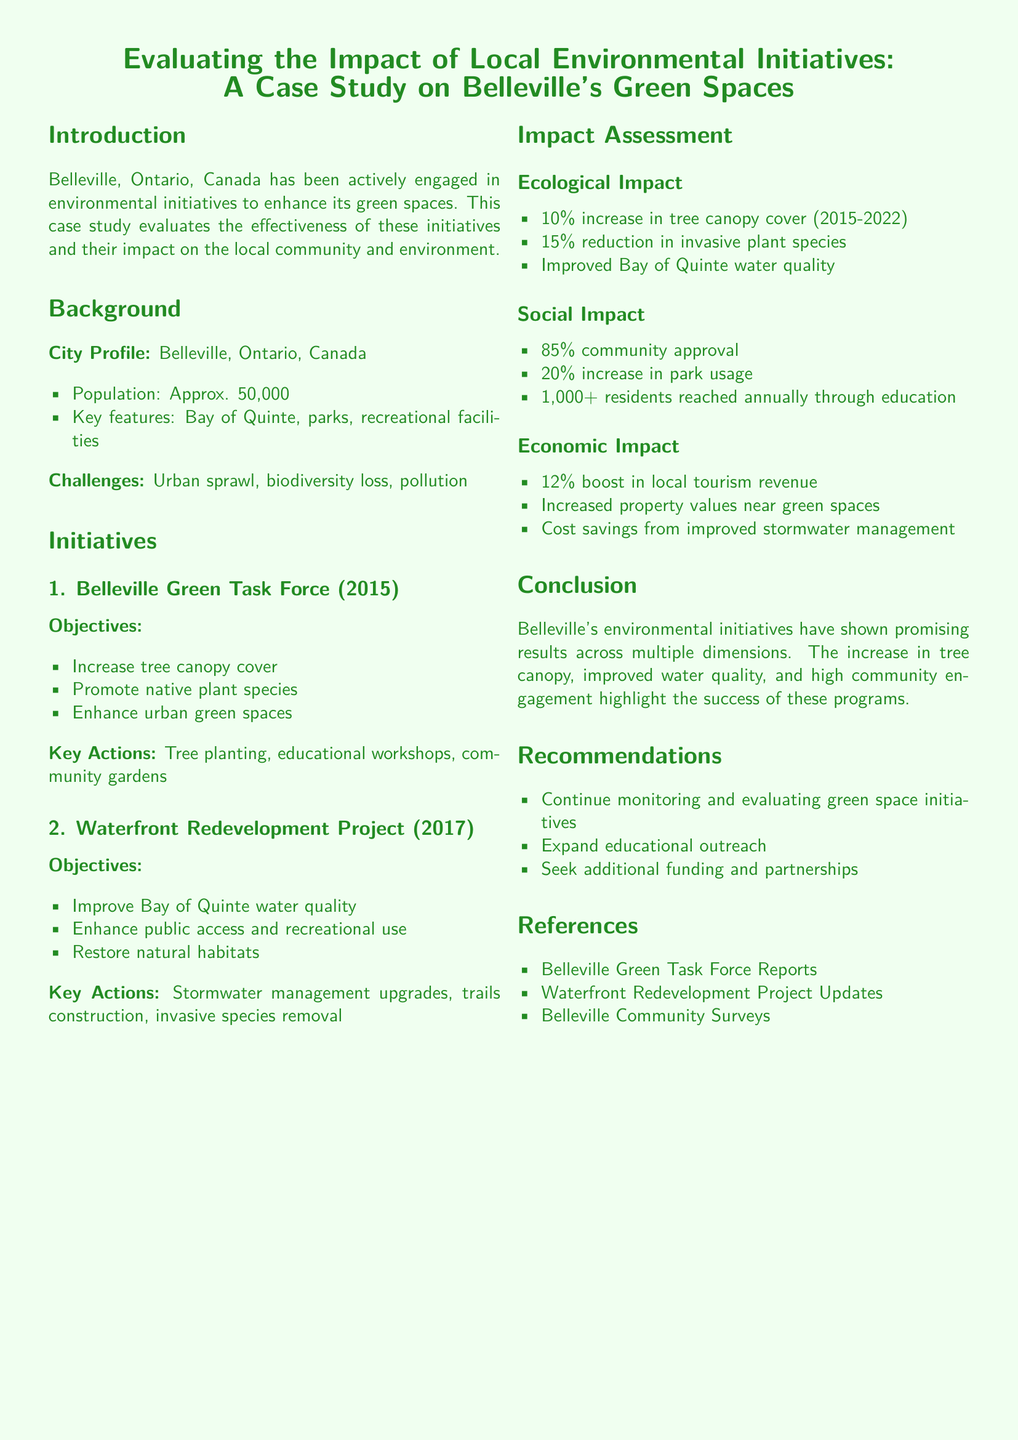What is the population of Belleville? The document states that the population of Belleville is approximately 50,000.
Answer: 50,000 What year was the Belleville Green Task Force established? According to the document, the Belleville Green Task Force was established in 2015.
Answer: 2015 What percentage increase in tree canopy cover was reported? The document indicates a 10% increase in tree canopy cover from 2015 to 2022.
Answer: 10% What is the community approval rate for the initiatives? The document notes that the community approval rate is 85%.
Answer: 85% Which project aimed to improve Bay of Quinte water quality? The Waterfront Redevelopment Project aimed to improve Bay of Quinte water quality.
Answer: Waterfront Redevelopment Project What was the percentage boost in local tourism revenue? The document reports a 12% boost in local tourism revenue.
Answer: 12% What is one key action taken by the Belleville Green Task Force? One key action mentioned for the Belleville Green Task Force is tree planting.
Answer: Tree planting What should be expanded according to the recommendations? The recommendations suggest expanding educational outreach.
Answer: Educational outreach What type of impact showed a 20% increase in park usage? The social impact showed a 20% increase in park usage in the document.
Answer: Social impact 